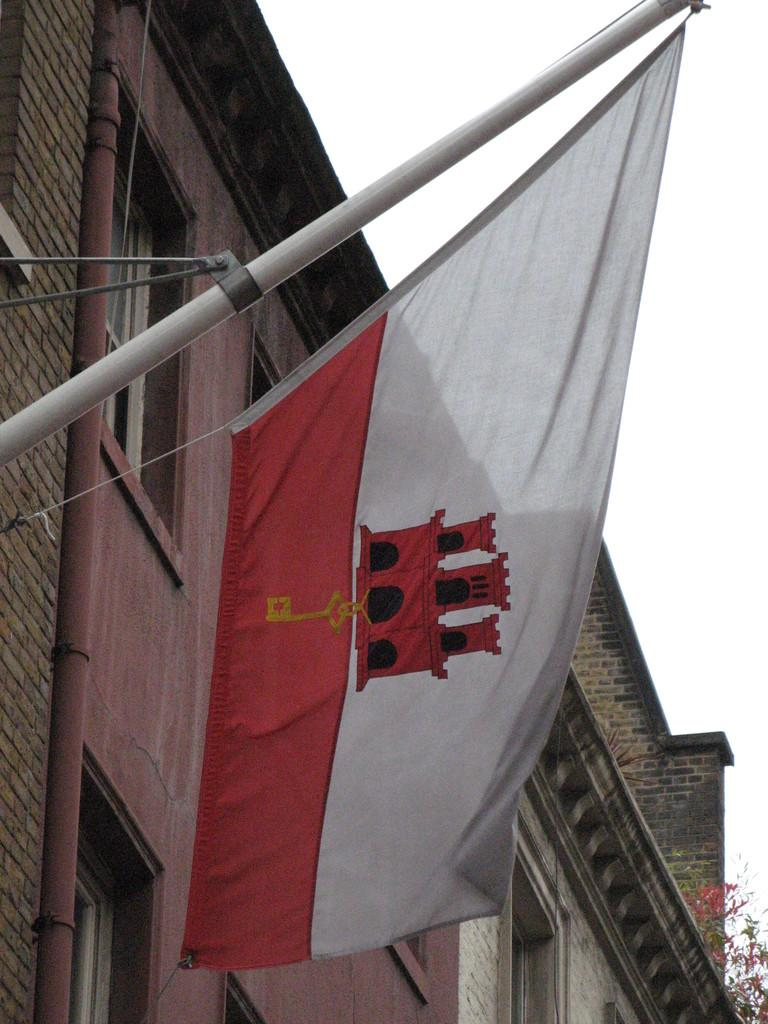What is present on the flag pole in the image? There is a flag on the flag pole in the image. What is depicted on the flag? The flag has a logo on it. What structure can be seen on the left side of the image? There is a building on the left side of the image. What type of vegetation is present in the image? There is a tree in the image. What is the condition of the sky in the image? The sky is clear in the image. What type of smell can be detected from the cows in the image? There are no cows present in the image, so it is not possible to detect any smell. What type of car is parked near the building in the image? There is no car present in the image; only a building, a tree, and a flag pole with a flag are visible. 